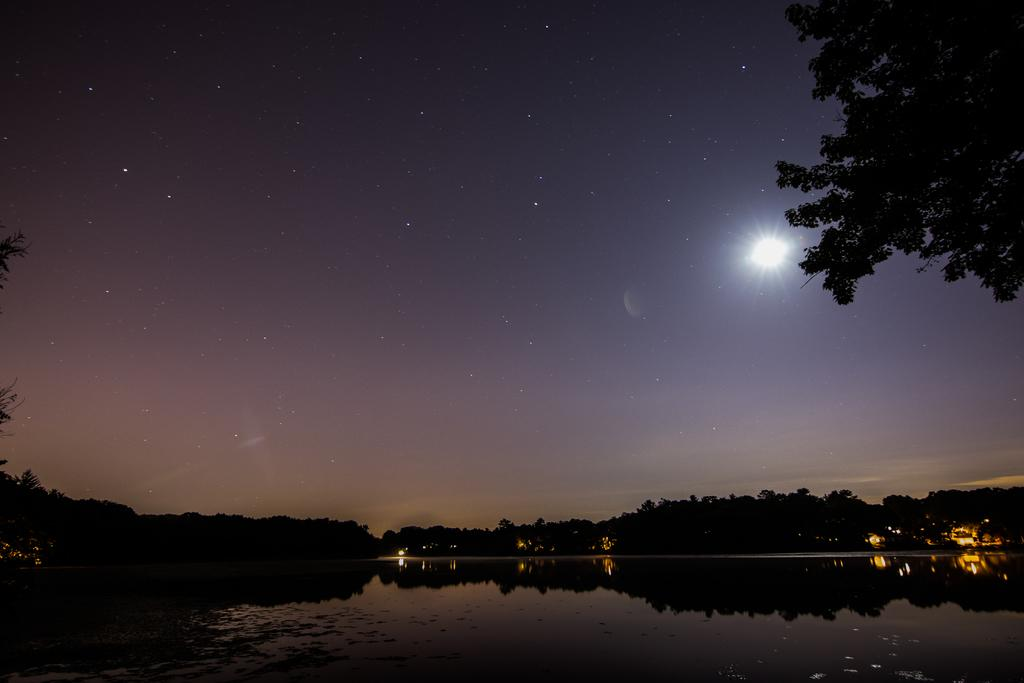What can be seen in the sky in the image? The sky with stars is visible in the image. What type of vegetation is present in the image? There are trees in the image. What natural element is visible in the image besides the sky and trees? There is water visible in the image. Can you tell me how many feathers are floating in the water in the image? There are no feathers present in the image; it features the sky with stars, trees, and water. Who is the uncle in the image? There is no uncle present in the image. 